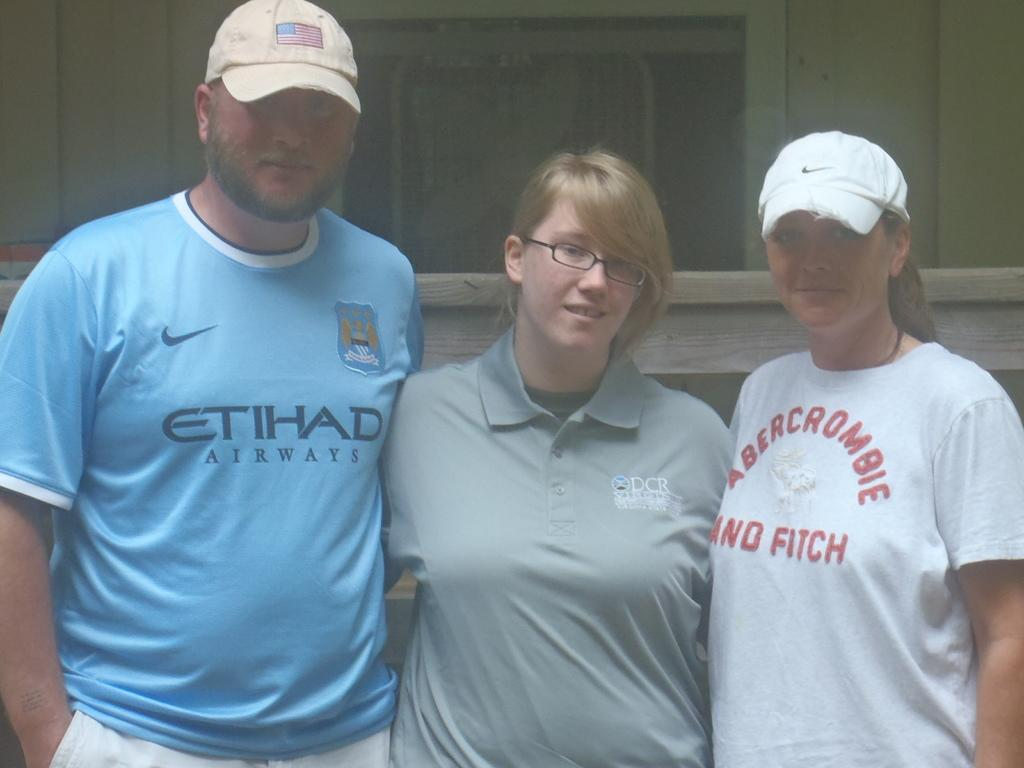<image>
Create a compact narrative representing the image presented. Three people are standing near each other and each have on t shirts that state a brand name like Abercrombie and Fitch and Etihad Airways. 